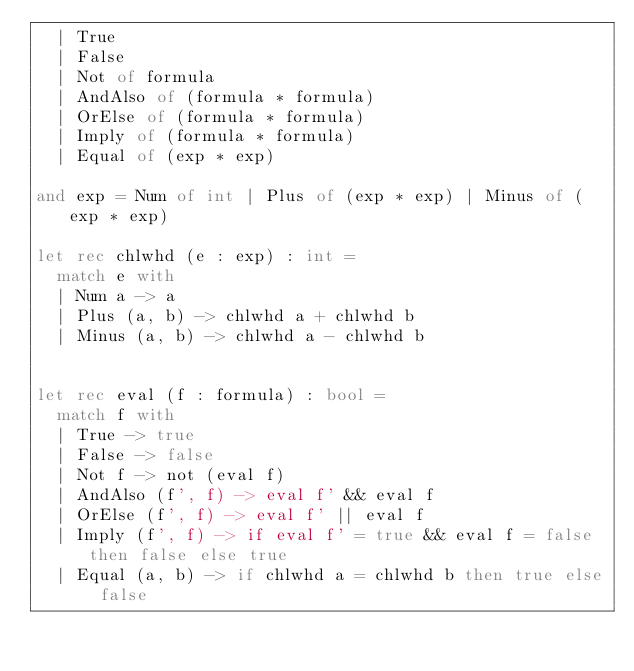Convert code to text. <code><loc_0><loc_0><loc_500><loc_500><_OCaml_>  | True
  | False
  | Not of formula
  | AndAlso of (formula * formula)
  | OrElse of (formula * formula)
  | Imply of (formula * formula)
  | Equal of (exp * exp)

and exp = Num of int | Plus of (exp * exp) | Minus of (exp * exp)

let rec chlwhd (e : exp) : int =
  match e with
  | Num a -> a
  | Plus (a, b) -> chlwhd a + chlwhd b
  | Minus (a, b) -> chlwhd a - chlwhd b


let rec eval (f : formula) : bool =
  match f with
  | True -> true
  | False -> false
  | Not f -> not (eval f)
  | AndAlso (f', f) -> eval f' && eval f
  | OrElse (f', f) -> eval f' || eval f
  | Imply (f', f) -> if eval f' = true && eval f = false then false else true
  | Equal (a, b) -> if chlwhd a = chlwhd b then true else false
</code> 